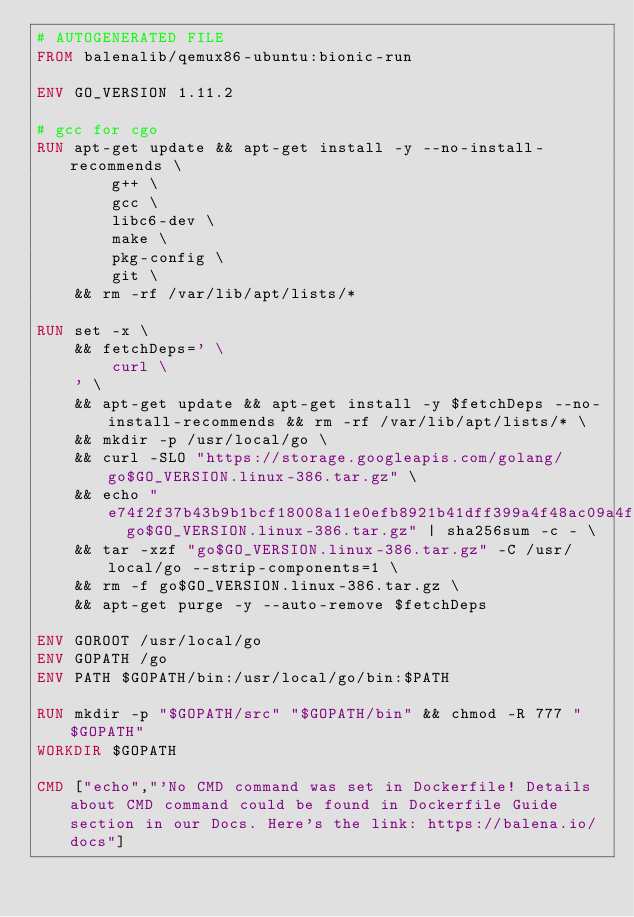<code> <loc_0><loc_0><loc_500><loc_500><_Dockerfile_># AUTOGENERATED FILE
FROM balenalib/qemux86-ubuntu:bionic-run

ENV GO_VERSION 1.11.2

# gcc for cgo
RUN apt-get update && apt-get install -y --no-install-recommends \
		g++ \
		gcc \
		libc6-dev \
		make \
		pkg-config \
		git \
	&& rm -rf /var/lib/apt/lists/*

RUN set -x \
	&& fetchDeps=' \
		curl \
	' \
	&& apt-get update && apt-get install -y $fetchDeps --no-install-recommends && rm -rf /var/lib/apt/lists/* \
	&& mkdir -p /usr/local/go \
	&& curl -SLO "https://storage.googleapis.com/golang/go$GO_VERSION.linux-386.tar.gz" \
	&& echo "e74f2f37b43b9b1bcf18008a11e0efb8921b41dff399a4f48ac09a4f25729881  go$GO_VERSION.linux-386.tar.gz" | sha256sum -c - \
	&& tar -xzf "go$GO_VERSION.linux-386.tar.gz" -C /usr/local/go --strip-components=1 \
	&& rm -f go$GO_VERSION.linux-386.tar.gz \
	&& apt-get purge -y --auto-remove $fetchDeps

ENV GOROOT /usr/local/go
ENV GOPATH /go
ENV PATH $GOPATH/bin:/usr/local/go/bin:$PATH

RUN mkdir -p "$GOPATH/src" "$GOPATH/bin" && chmod -R 777 "$GOPATH"
WORKDIR $GOPATH

CMD ["echo","'No CMD command was set in Dockerfile! Details about CMD command could be found in Dockerfile Guide section in our Docs. Here's the link: https://balena.io/docs"]</code> 